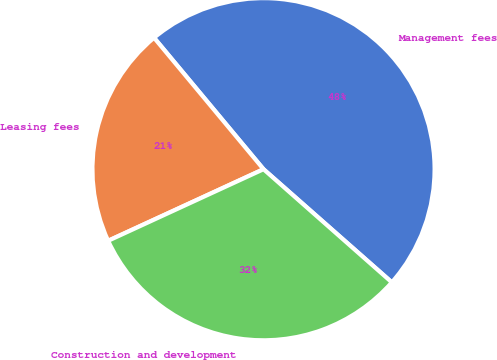Convert chart. <chart><loc_0><loc_0><loc_500><loc_500><pie_chart><fcel>Management fees<fcel>Leasing fees<fcel>Construction and development<nl><fcel>47.55%<fcel>20.82%<fcel>31.63%<nl></chart> 